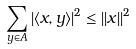Convert formula to latex. <formula><loc_0><loc_0><loc_500><loc_500>\sum _ { y \in A } | \langle x , y \rangle | ^ { 2 } \leq | | x | | ^ { 2 }</formula> 